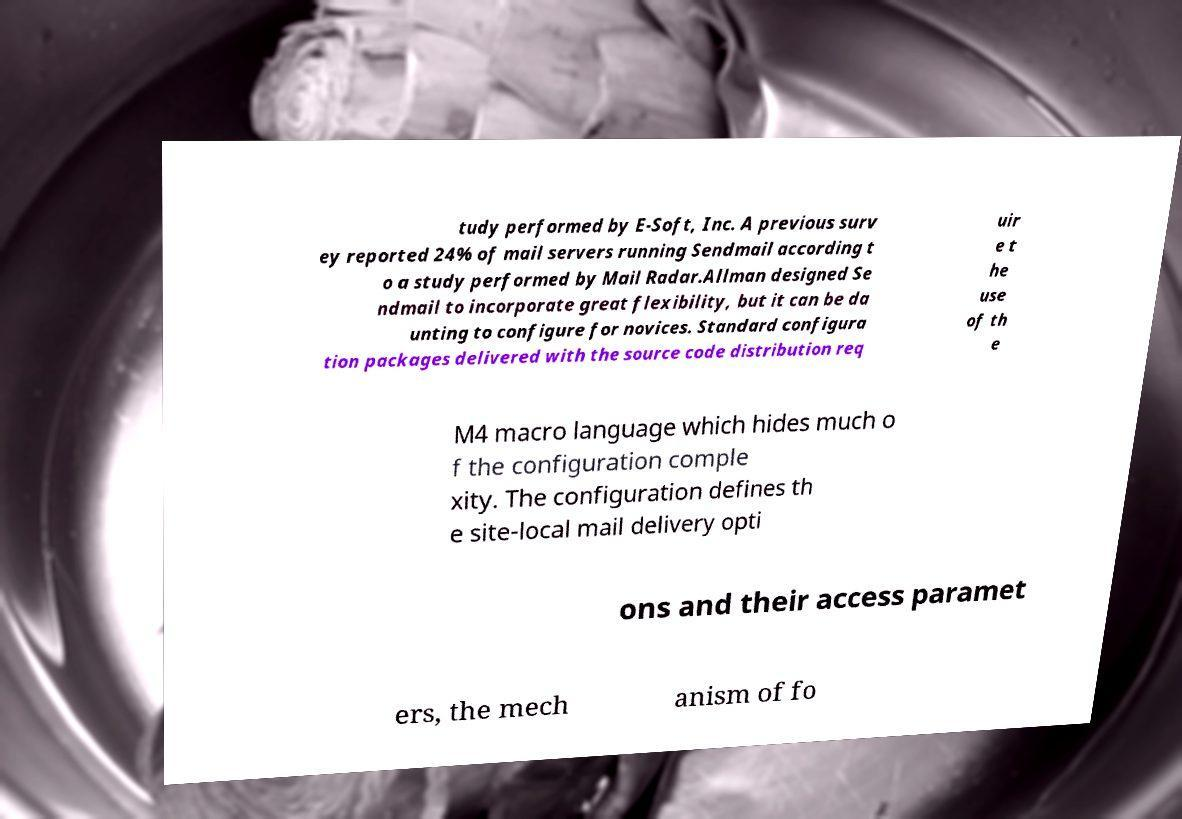Can you accurately transcribe the text from the provided image for me? tudy performed by E-Soft, Inc. A previous surv ey reported 24% of mail servers running Sendmail according t o a study performed by Mail Radar.Allman designed Se ndmail to incorporate great flexibility, but it can be da unting to configure for novices. Standard configura tion packages delivered with the source code distribution req uir e t he use of th e M4 macro language which hides much o f the configuration comple xity. The configuration defines th e site-local mail delivery opti ons and their access paramet ers, the mech anism of fo 